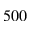<formula> <loc_0><loc_0><loc_500><loc_500>5 0 0</formula> 